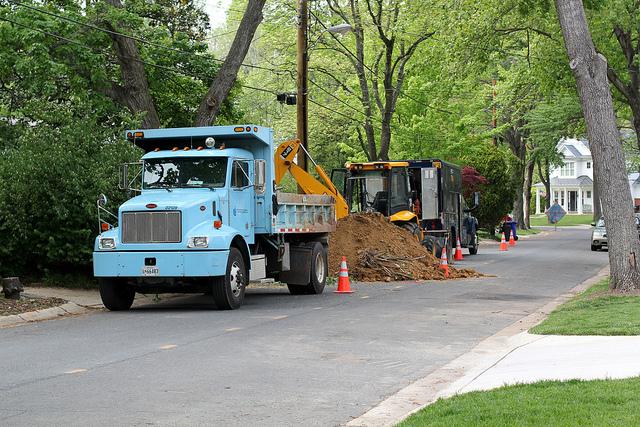Do you see a fire truck in the picture?
Keep it brief. No. How many orange cones are there?
Give a very brief answer. 5. Is there a girl in a pink shit in the picture?
Be succinct. No. How many cones?
Concise answer only. 5. Are these trucks on a highway?
Short answer required. No. What is the machine used for?
Be succinct. Hauling. What color is the truck?
Keep it brief. Blue. 